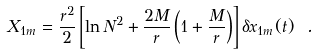Convert formula to latex. <formula><loc_0><loc_0><loc_500><loc_500>X _ { 1 m } = \frac { r ^ { 2 } } { 2 } \left [ \ln N ^ { 2 } + \frac { 2 M } { r } \left ( 1 + \frac { M } { r } \right ) \right ] \delta x _ { 1 m } ( t ) \ .</formula> 